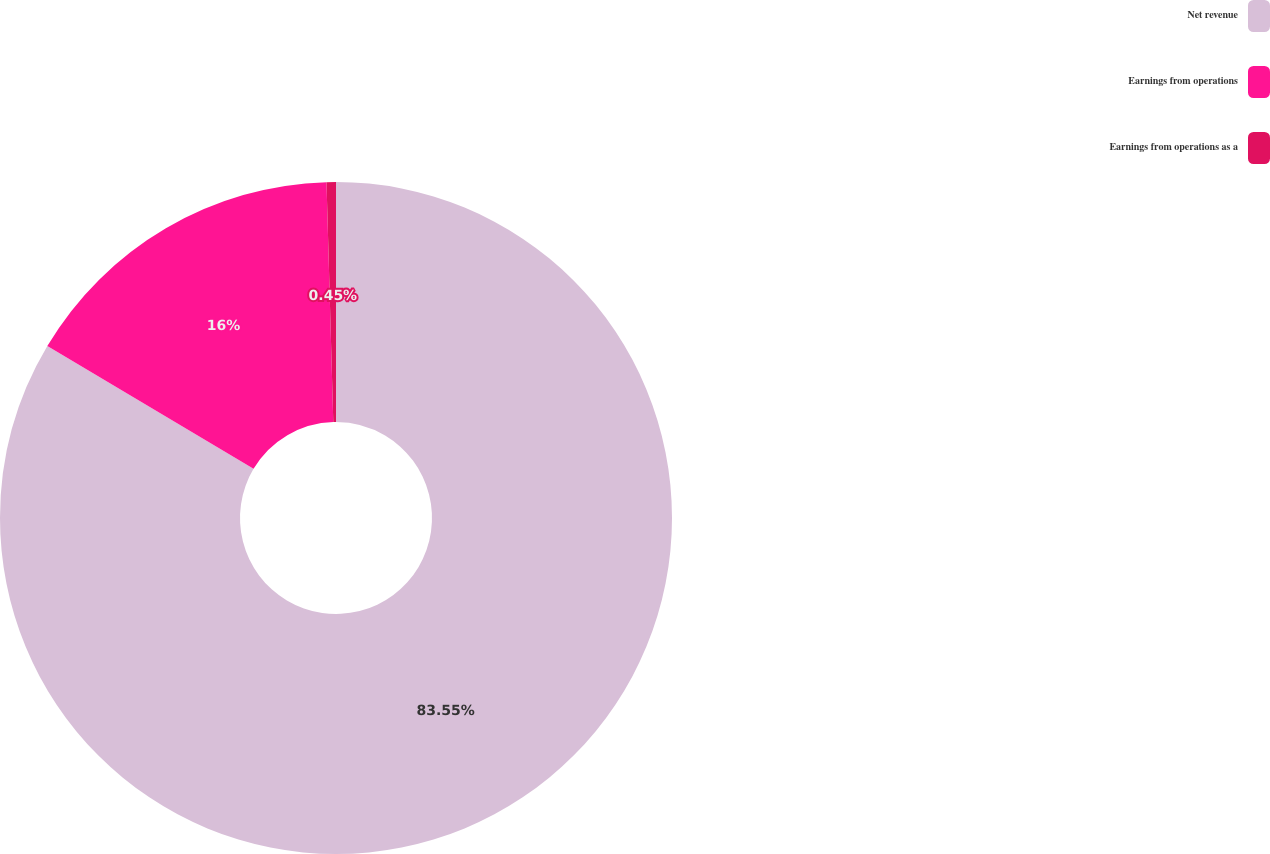<chart> <loc_0><loc_0><loc_500><loc_500><pie_chart><fcel>Net revenue<fcel>Earnings from operations<fcel>Earnings from operations as a<nl><fcel>83.55%<fcel>16.0%<fcel>0.45%<nl></chart> 